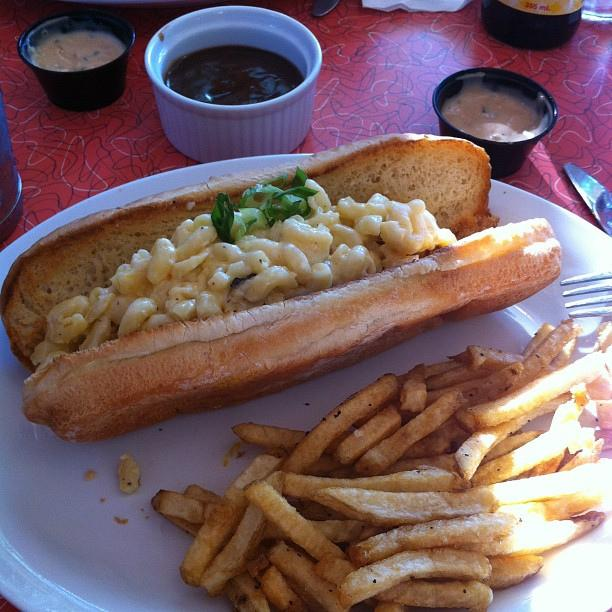What would usually be where the pasta is? Please explain your reasoning. hot dog. This is a hot dog bun and normally there would be some kind of long meat in it 